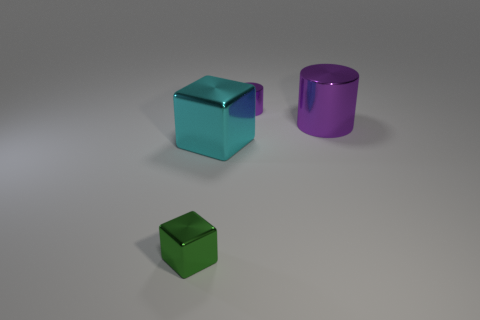Subtract all blue cylinders. Subtract all purple blocks. How many cylinders are left? 2 Add 2 tiny purple metal cylinders. How many objects exist? 6 Add 3 big objects. How many big objects exist? 5 Subtract 0 brown cylinders. How many objects are left? 4 Subtract all big purple cylinders. Subtract all small metal cylinders. How many objects are left? 2 Add 1 big cubes. How many big cubes are left? 2 